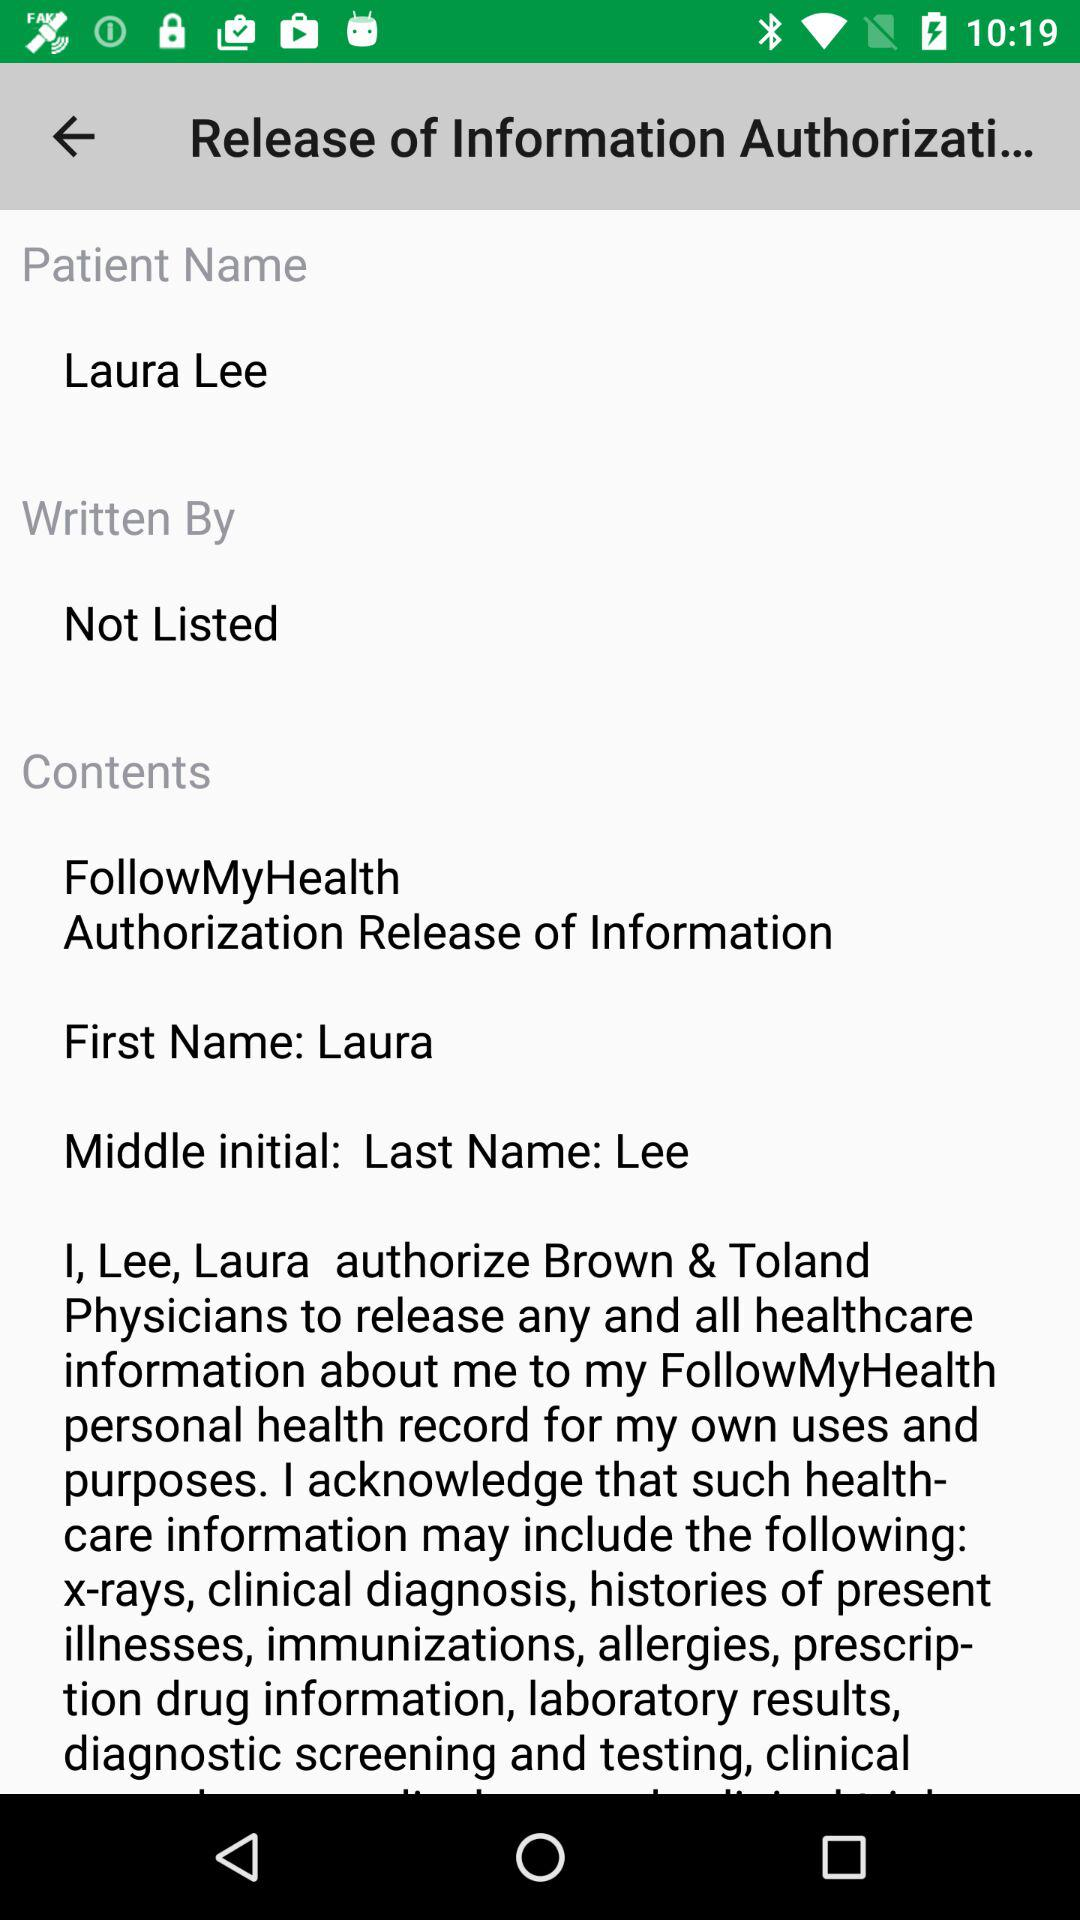What details are included in the healthcare information? The details about x-rays, clinical diagnosis, histories of present illnesses, immunizations, allergies, prescription drug information, laboratory results, diagnostic screening and testing are included in the healthcare information. 